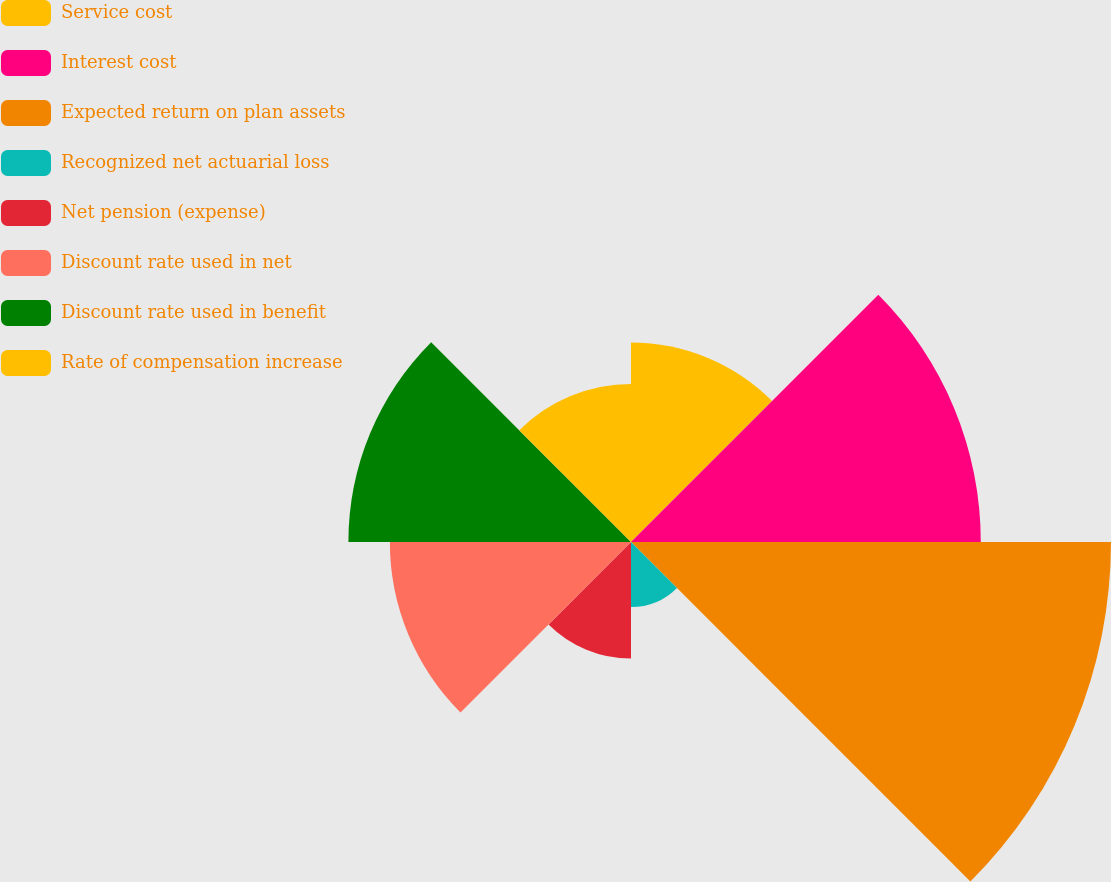Convert chart to OTSL. <chart><loc_0><loc_0><loc_500><loc_500><pie_chart><fcel>Service cost<fcel>Interest cost<fcel>Expected return on plan assets<fcel>Recognized net actuarial loss<fcel>Net pension (expense)<fcel>Discount rate used in net<fcel>Discount rate used in benefit<fcel>Rate of compensation increase<nl><fcel>10.54%<fcel>18.48%<fcel>25.36%<fcel>3.44%<fcel>6.16%<fcel>12.74%<fcel>14.93%<fcel>8.35%<nl></chart> 